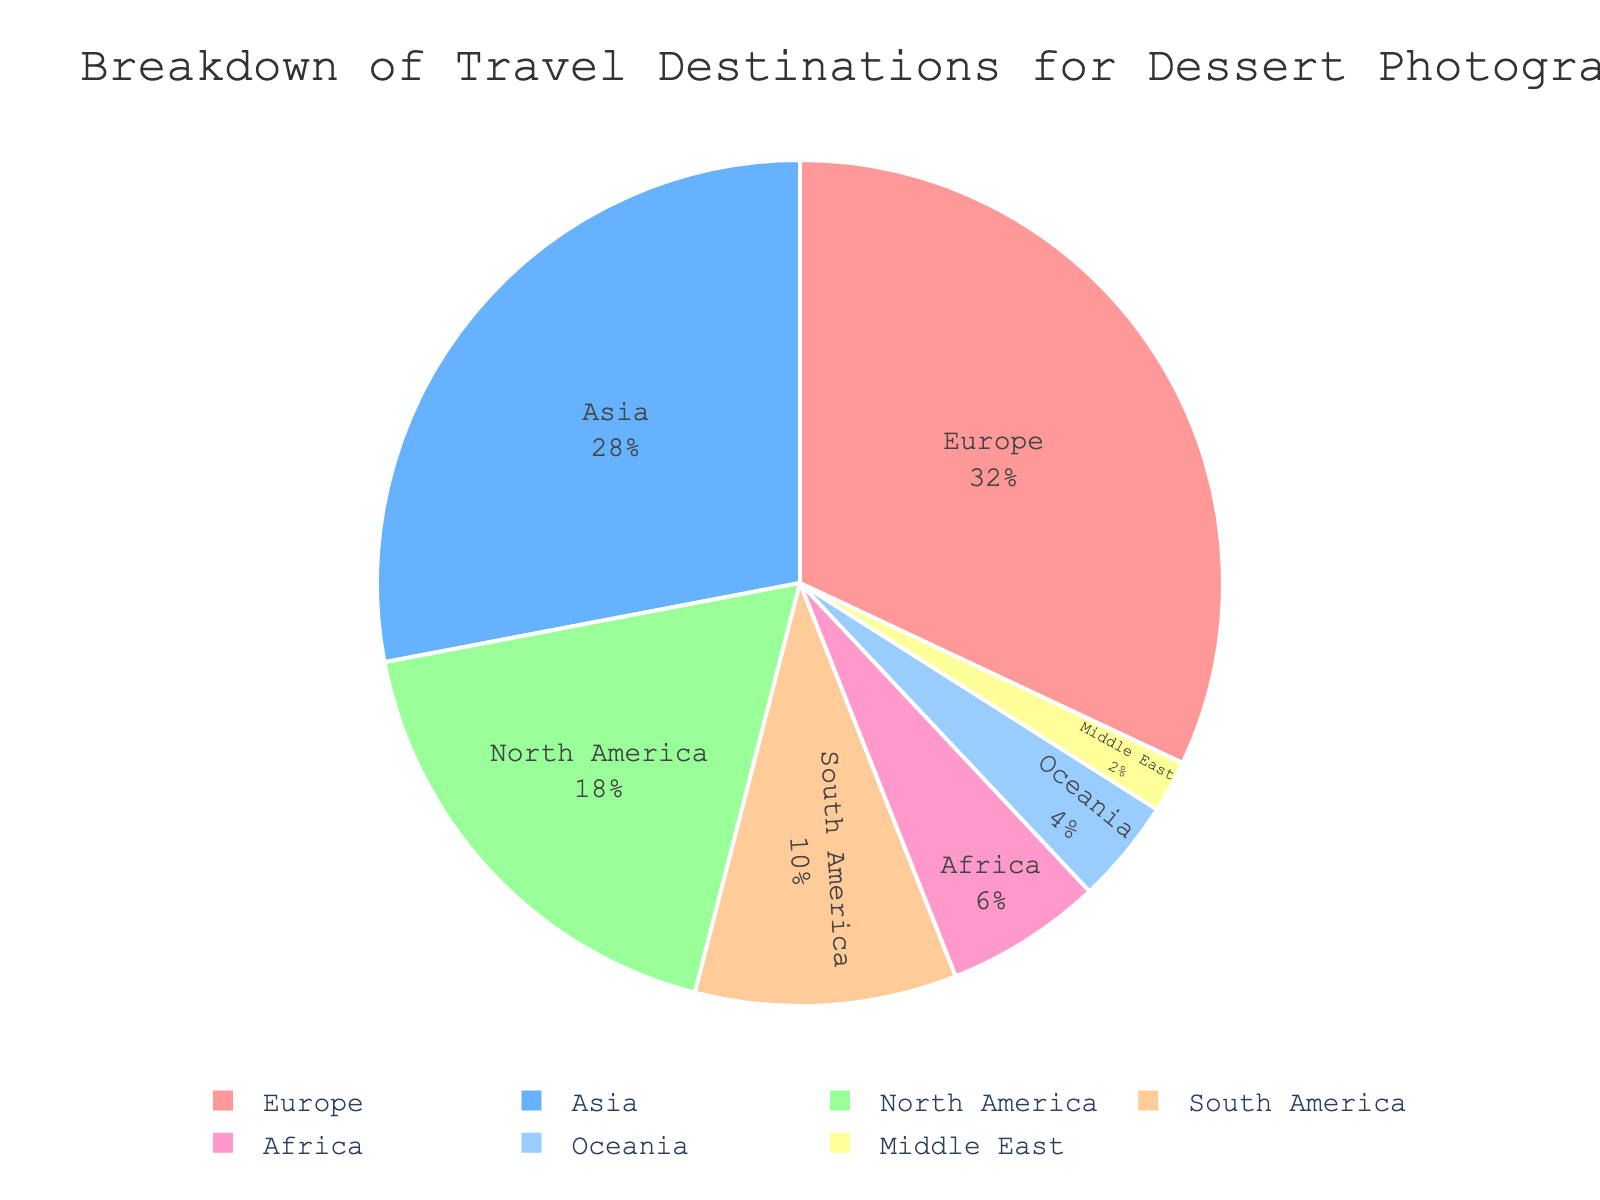Which continent has the largest percentage of travel destinations for dessert photography? The figure shows that Europe has the largest segment in the pie chart, representing the highest percentage.
Answer: Europe What percentage of travel destinations fall within Asia and Oceania combined? Add the percentage values for Asia (28%) and Oceania (4%): 28 + 4 = 32.
Answer: 32% How does the percentage of travel to North America compare to South America? North America has 18% and South America has 10%. Subtract the percentage of South America from North America: 18 - 10 = 8. North America has 8% more than South America.
Answer: North America has 8% more What is the total percentage of travel destinations that are less than 10% each? Sum the percentages of Africa (6%), Oceania (4%), and Middle East (2%): 6 + 4 + 2 = 12.
Answer: 12% How does the combined percentage of Europe and Asia compare to the combined percentage of North and South America? Combine Europe (32%) and Asia (28%): 32 + 28 = 60. Combine North America (18%) and South America (10%): 18 + 10 = 28. Subtract the combined percentage of the Americas from Europe and Asia: 60 - 28 = 32.
Answer: 32% more Which continent has the smallest visual segment in the pie chart? The smallest visual segment is labeled as the Middle East, which represents the smallest percentage.
Answer: Middle East What percent of the total is represented by continents in the Southern Hemisphere? Sum the percentages for South America (10%), Africa (6%), and Oceania (4%): 10 + 6 + 4 = 20.
Answer: 20% By what factor is Europe's percentage larger than that of the Middle East? Divide the percentage of Europe (32%) by the percentage of the Middle East (2%): 32 / 2 = 16.
Answer: 16 Which continents combined make up more than 50% of the total travel destinations? Europe and Asia together contribute 32 + 28 = 60, which is more than 50%. North America and South America together contribute a total of 18 + 10 = 28, which is less than 50%. Therefore, only Europe and Asia together constitute more than 50%.
Answer: Europe and Asia 